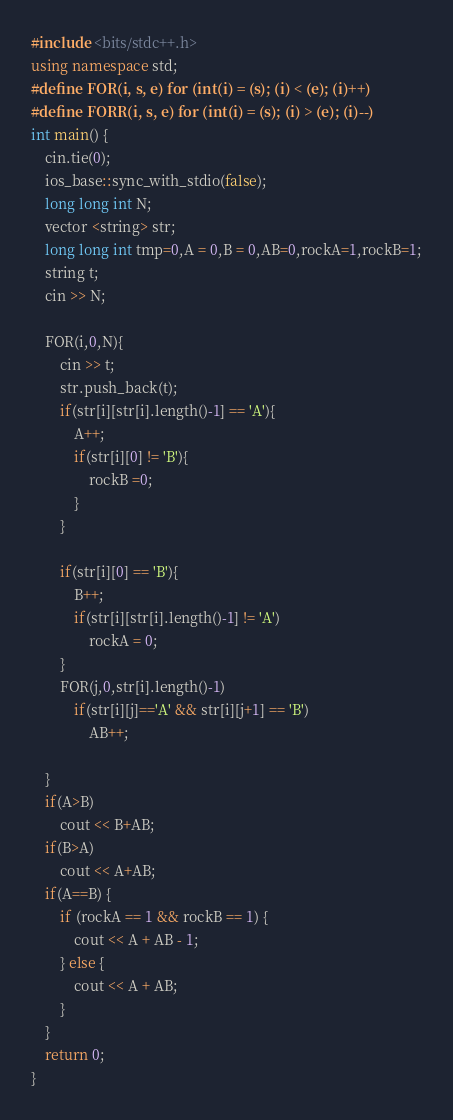<code> <loc_0><loc_0><loc_500><loc_500><_C++_>#include <bits/stdc++.h>
using namespace std;
#define FOR(i, s, e) for (int(i) = (s); (i) < (e); (i)++)
#define FORR(i, s, e) for (int(i) = (s); (i) > (e); (i)--)
int main() {
    cin.tie(0);
    ios_base::sync_with_stdio(false);
    long long int N;
    vector <string> str;
    long long int tmp=0,A = 0,B = 0,AB=0,rockA=1,rockB=1;
    string t;
    cin >> N;

    FOR(i,0,N){
        cin >> t;
        str.push_back(t);
        if(str[i][str[i].length()-1] == 'A'){
            A++;
            if(str[i][0] != 'B'){
                rockB =0;
            }
        }

        if(str[i][0] == 'B'){
            B++;
            if(str[i][str[i].length()-1] != 'A')
                rockA = 0;
        }
        FOR(j,0,str[i].length()-1)
            if(str[i][j]=='A' && str[i][j+1] == 'B')
                AB++;

    }
    if(A>B)
        cout << B+AB;
    if(B>A)
        cout << A+AB;
    if(A==B) {
        if (rockA == 1 && rockB == 1) {
            cout << A + AB - 1;
        } else {
            cout << A + AB;
        }
    }
    return 0;
}</code> 